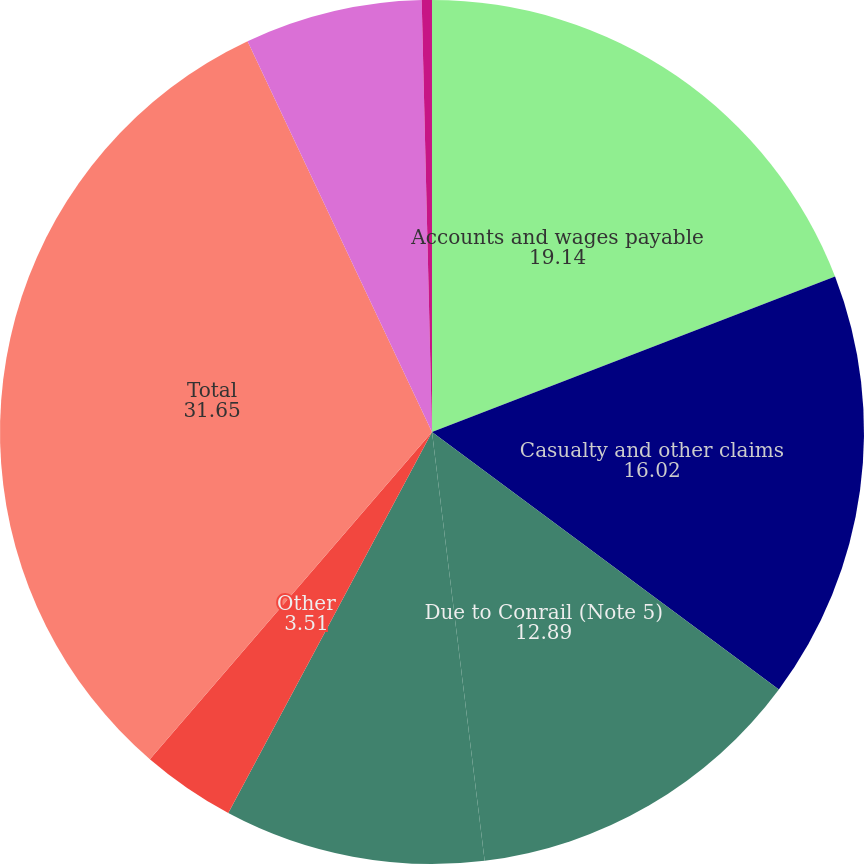<chart> <loc_0><loc_0><loc_500><loc_500><pie_chart><fcel>Accounts and wages payable<fcel>Casualty and other claims<fcel>Due to Conrail (Note 5)<fcel>Vacation liability<fcel>Other<fcel>Total<fcel>Interest payable<fcel>Pension benefit obligations<nl><fcel>19.14%<fcel>16.02%<fcel>12.89%<fcel>9.76%<fcel>3.51%<fcel>31.65%<fcel>6.64%<fcel>0.38%<nl></chart> 